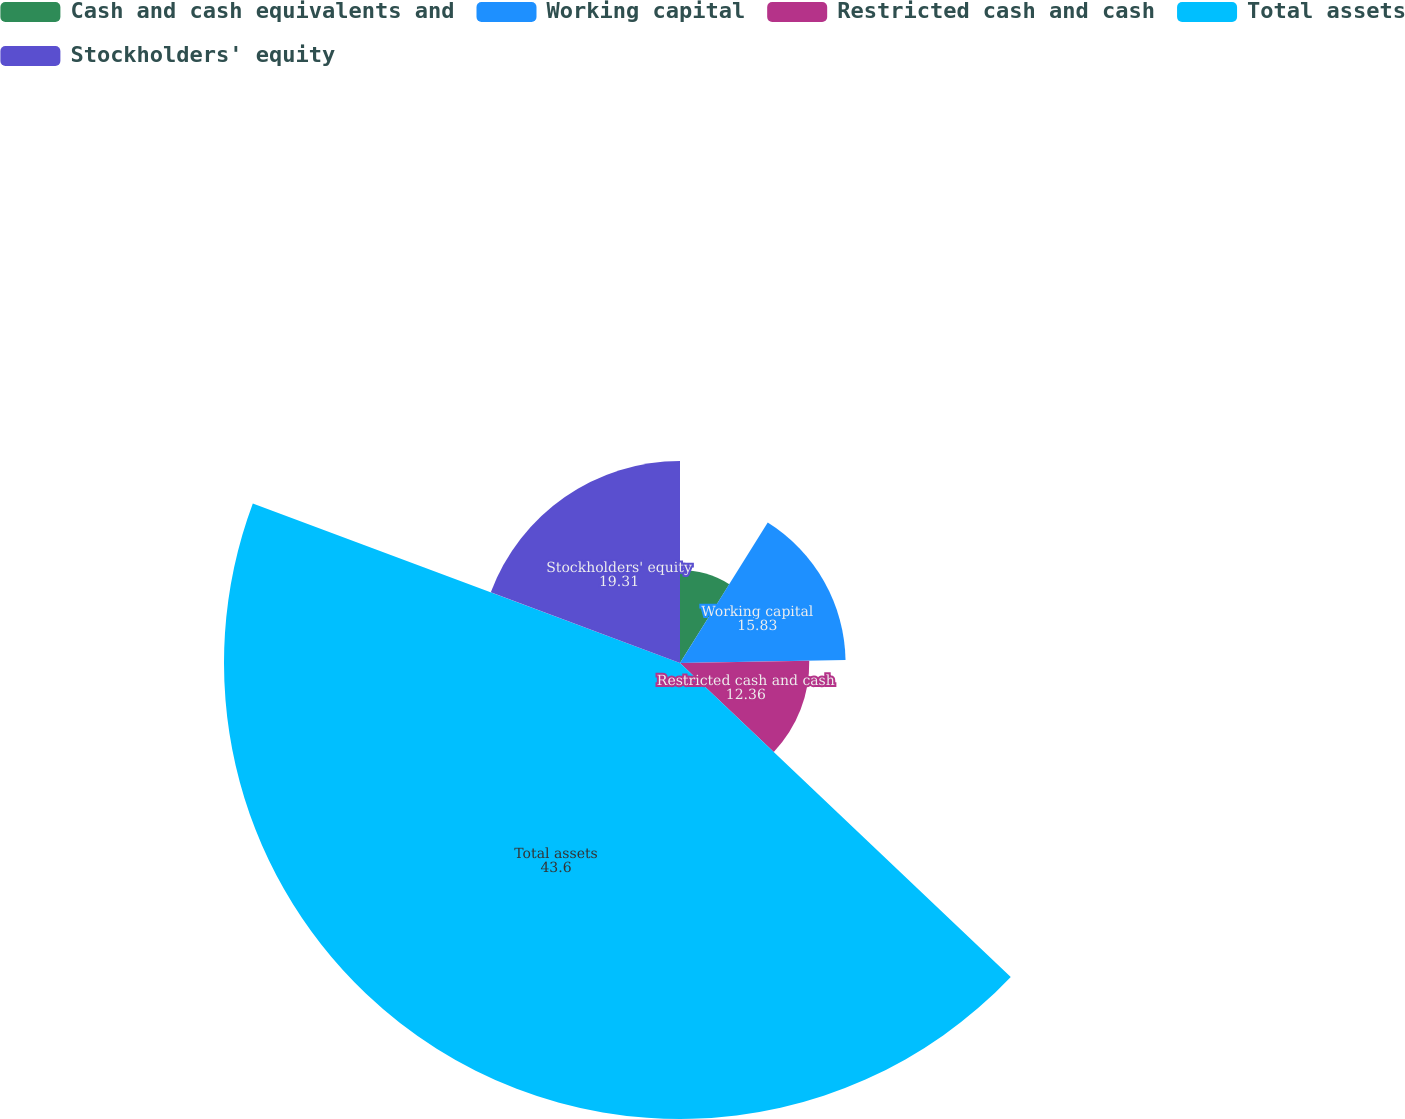Convert chart. <chart><loc_0><loc_0><loc_500><loc_500><pie_chart><fcel>Cash and cash equivalents and<fcel>Working capital<fcel>Restricted cash and cash<fcel>Total assets<fcel>Stockholders' equity<nl><fcel>8.89%<fcel>15.83%<fcel>12.36%<fcel>43.6%<fcel>19.31%<nl></chart> 